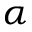<formula> <loc_0><loc_0><loc_500><loc_500>\alpha</formula> 